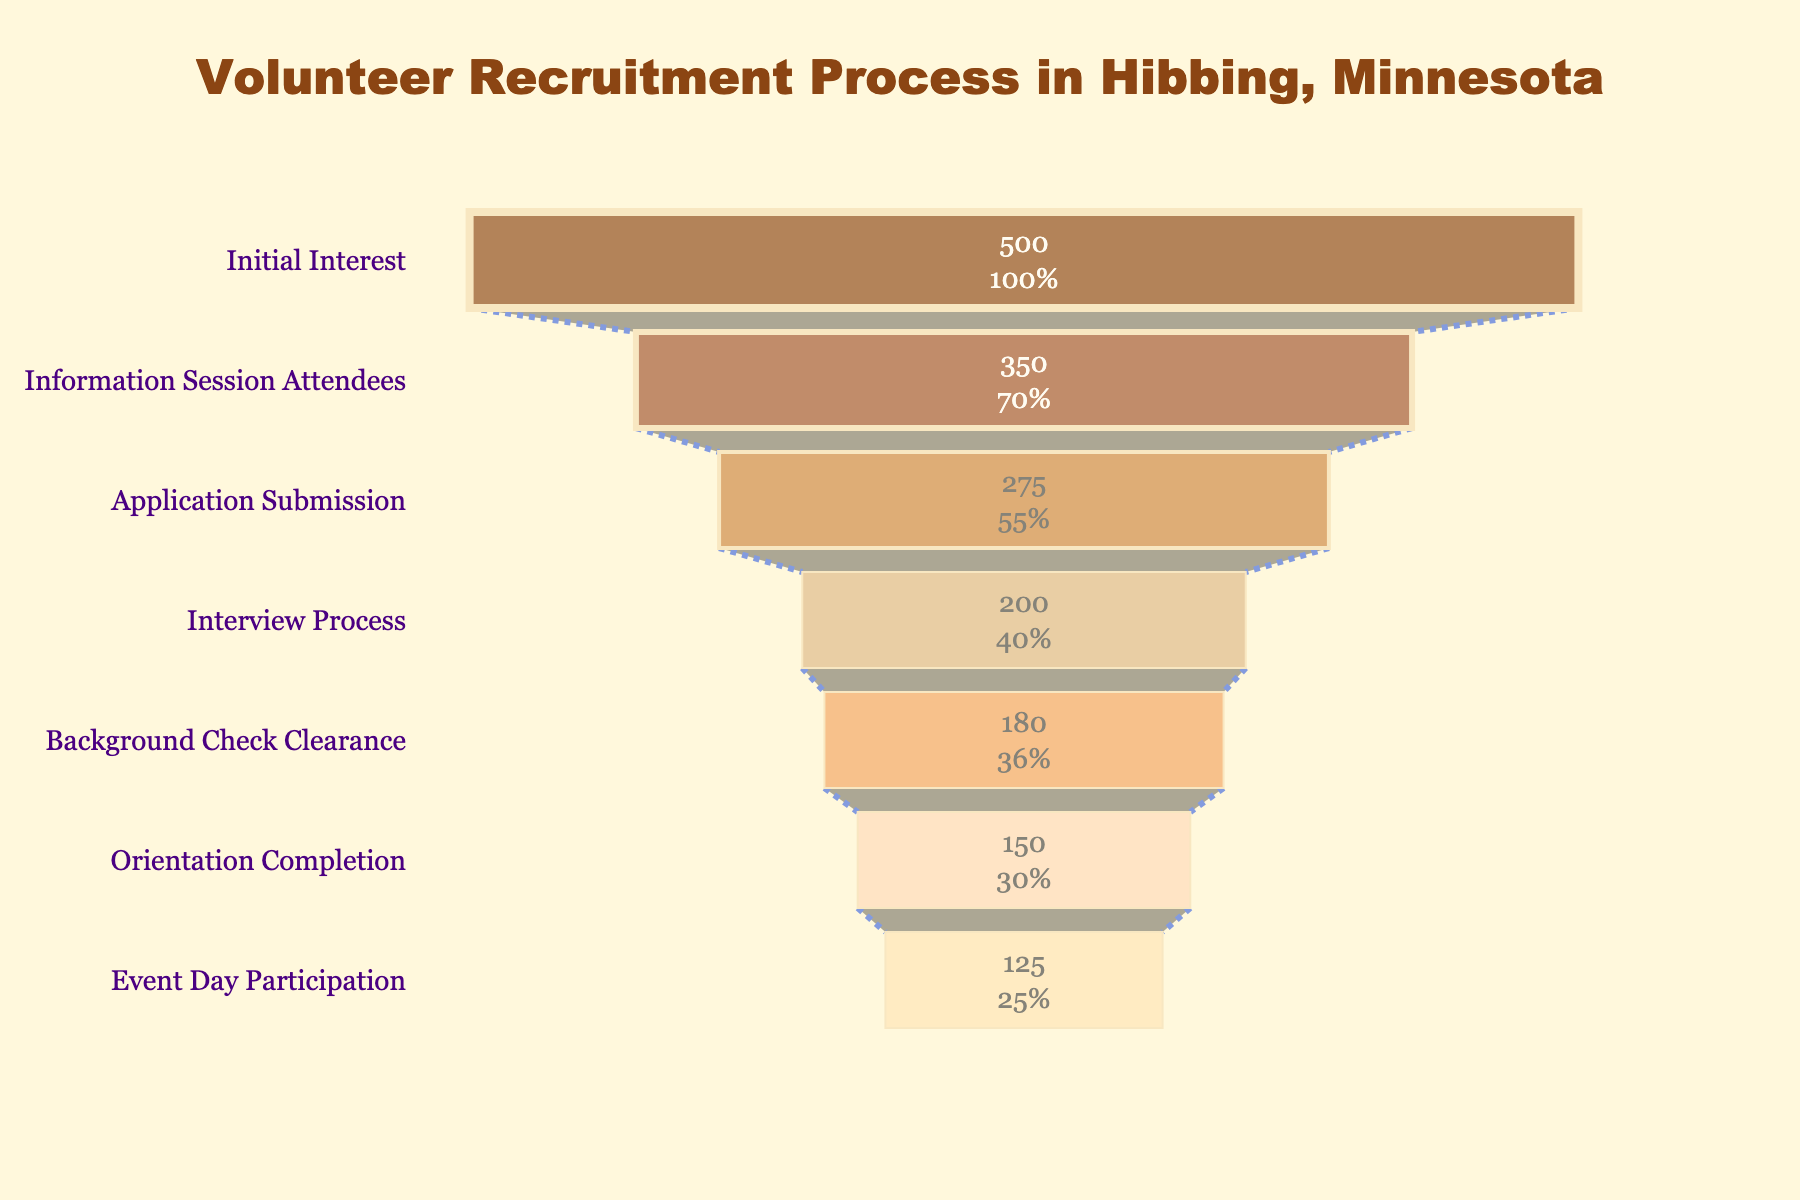What is the title of the funnel chart? The title is written at the top of the chart, indicating the subject of the data displayed. The title reads "Volunteer Recruitment Process in Hibbing, Minnesota".
Answer: Volunteer Recruitment Process in Hibbing, Minnesota What is the initial number of people who showed interest? The first stage of the funnel chart labeled "Initial Interest" shows the number of people in that stage.
Answer: 500 How many people attended the information session? The second stage of the funnel chart labeled "Information Session Attendees" shows the number of people in that stage.
Answer: 350 What is the percentage of people who progressed from "Initial Interest" to "Information Session Attendees"? Calculate the percentage by dividing the number of people who attended the information session (350) by the number of people who showed initial interest (500) and then multiply by 100. (350/500) * 100 = 70%
Answer: 70% How many people completed the background check clearance? The fifth stage of the funnel chart labeled "Background Check Clearance" shows the number of people in that stage.
Answer: 180 What is the attrition from the "Interview Process" to "Background Check Clearance"? To find the attrition, subtract the number of people who cleared the background check (180) from the number who were in the interview process (200). 200 - 180 = 20
Answer: 20 How many people attended the orientation completion? The sixth stage of the funnel chart labeled "Orientation Completion" shows the number of people in that stage.
Answer: 150 Out of the people who completed the orientation, what percentage actually participated on the event day? Calculate the percentage by dividing the number of people who participated on the event day (125) by the number who completed the orientation (150) and then multiply by 100. (125/150) * 100 = 83.33%
Answer: 83.33% Which stage has the greatest drop in numbers and by how much? Compare the numbers at each stage; the greatest drop is from "Initial Interest" (500) to "Information Session Attendees" (350). Subtract 350 from 500. 500 - 350 = 150
Answer: 150 What percentage of the total initial interested people participated on the event day? To find the percentage, divide the number of people who participated on the event day (125) by the initial number of people who showed interest (500) and then multiply by 100. (125/500) * 100 = 25%
Answer: 25% 